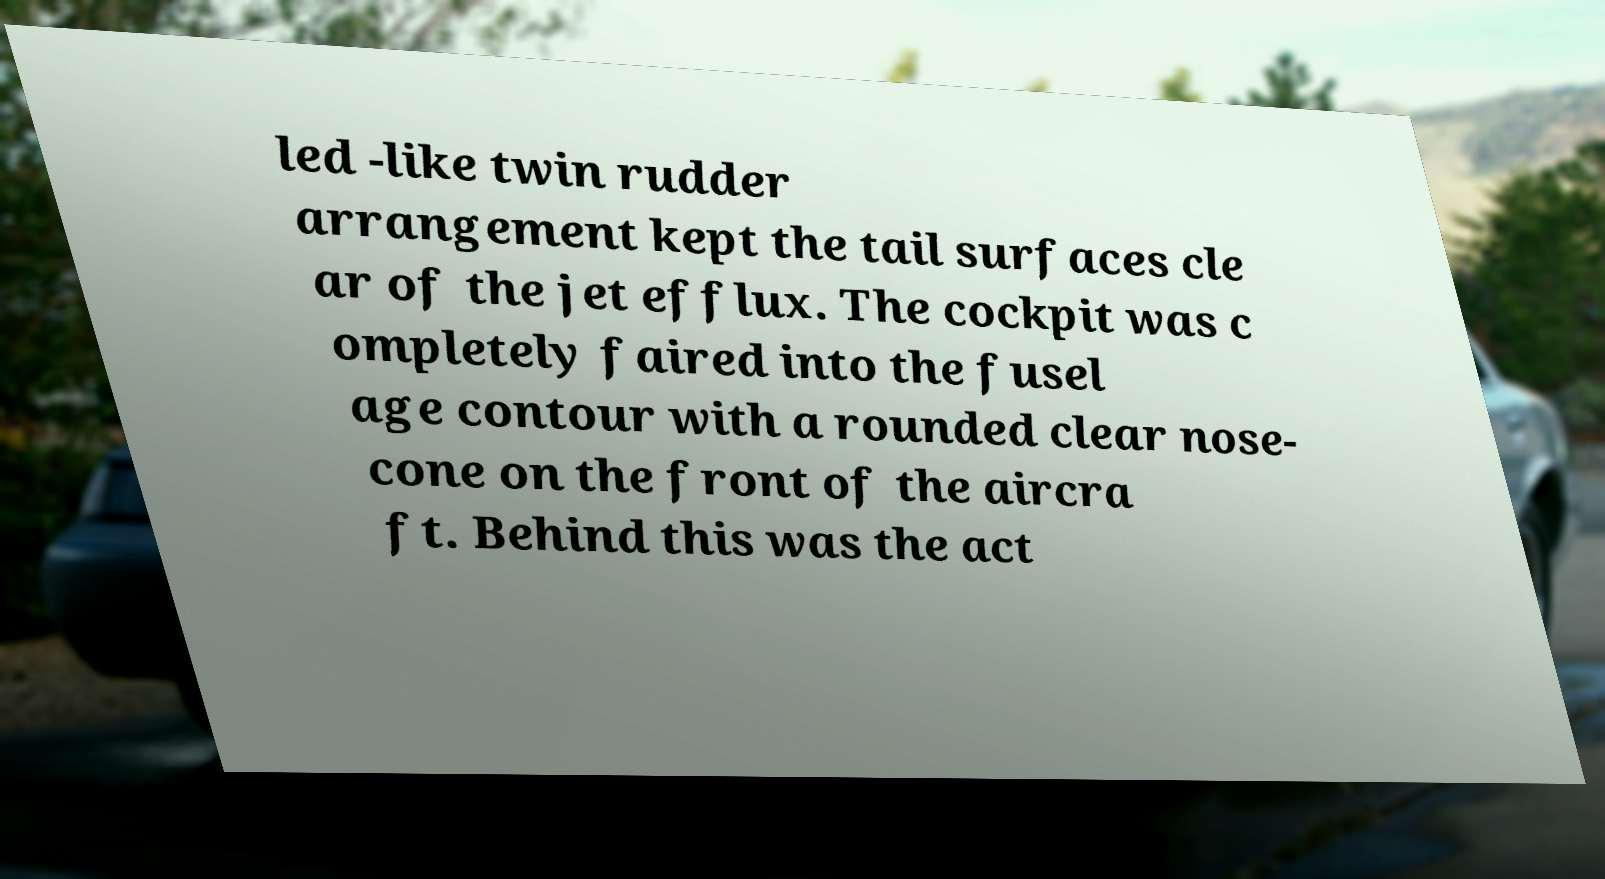Please read and relay the text visible in this image. What does it say? led -like twin rudder arrangement kept the tail surfaces cle ar of the jet efflux. The cockpit was c ompletely faired into the fusel age contour with a rounded clear nose- cone on the front of the aircra ft. Behind this was the act 